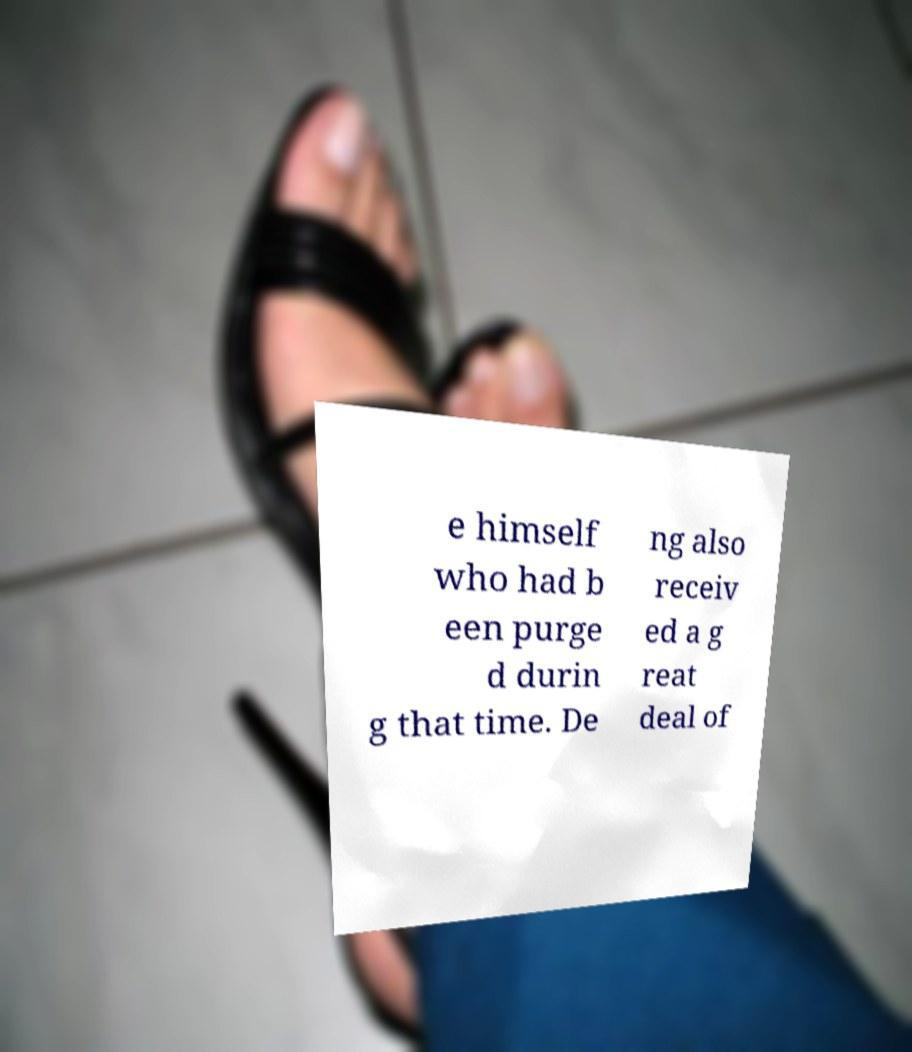Please identify and transcribe the text found in this image. e himself who had b een purge d durin g that time. De ng also receiv ed a g reat deal of 